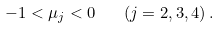<formula> <loc_0><loc_0><loc_500><loc_500>- 1 < \mu _ { j } < 0 \quad ( j = 2 , 3 , 4 ) \, .</formula> 